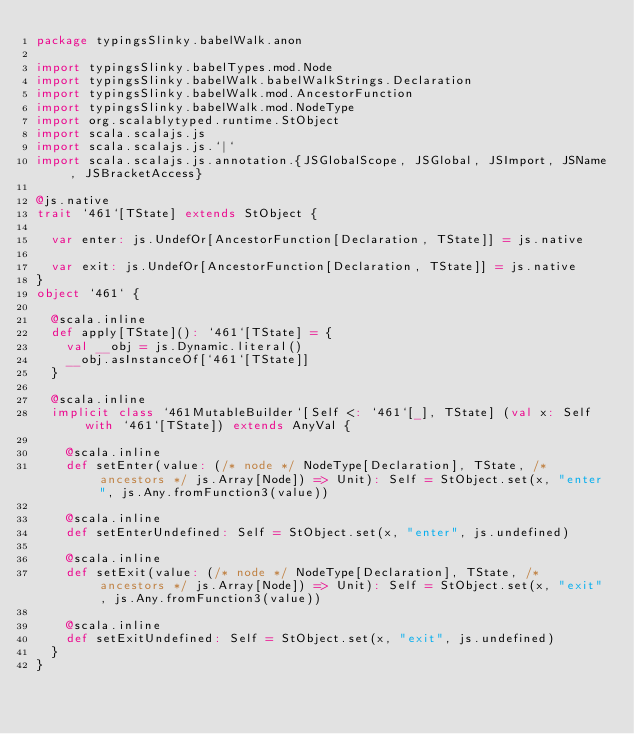Convert code to text. <code><loc_0><loc_0><loc_500><loc_500><_Scala_>package typingsSlinky.babelWalk.anon

import typingsSlinky.babelTypes.mod.Node
import typingsSlinky.babelWalk.babelWalkStrings.Declaration
import typingsSlinky.babelWalk.mod.AncestorFunction
import typingsSlinky.babelWalk.mod.NodeType
import org.scalablytyped.runtime.StObject
import scala.scalajs.js
import scala.scalajs.js.`|`
import scala.scalajs.js.annotation.{JSGlobalScope, JSGlobal, JSImport, JSName, JSBracketAccess}

@js.native
trait `461`[TState] extends StObject {
  
  var enter: js.UndefOr[AncestorFunction[Declaration, TState]] = js.native
  
  var exit: js.UndefOr[AncestorFunction[Declaration, TState]] = js.native
}
object `461` {
  
  @scala.inline
  def apply[TState](): `461`[TState] = {
    val __obj = js.Dynamic.literal()
    __obj.asInstanceOf[`461`[TState]]
  }
  
  @scala.inline
  implicit class `461MutableBuilder`[Self <: `461`[_], TState] (val x: Self with `461`[TState]) extends AnyVal {
    
    @scala.inline
    def setEnter(value: (/* node */ NodeType[Declaration], TState, /* ancestors */ js.Array[Node]) => Unit): Self = StObject.set(x, "enter", js.Any.fromFunction3(value))
    
    @scala.inline
    def setEnterUndefined: Self = StObject.set(x, "enter", js.undefined)
    
    @scala.inline
    def setExit(value: (/* node */ NodeType[Declaration], TState, /* ancestors */ js.Array[Node]) => Unit): Self = StObject.set(x, "exit", js.Any.fromFunction3(value))
    
    @scala.inline
    def setExitUndefined: Self = StObject.set(x, "exit", js.undefined)
  }
}
</code> 